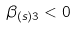<formula> <loc_0><loc_0><loc_500><loc_500>\beta _ { ( s ) 3 } < 0</formula> 